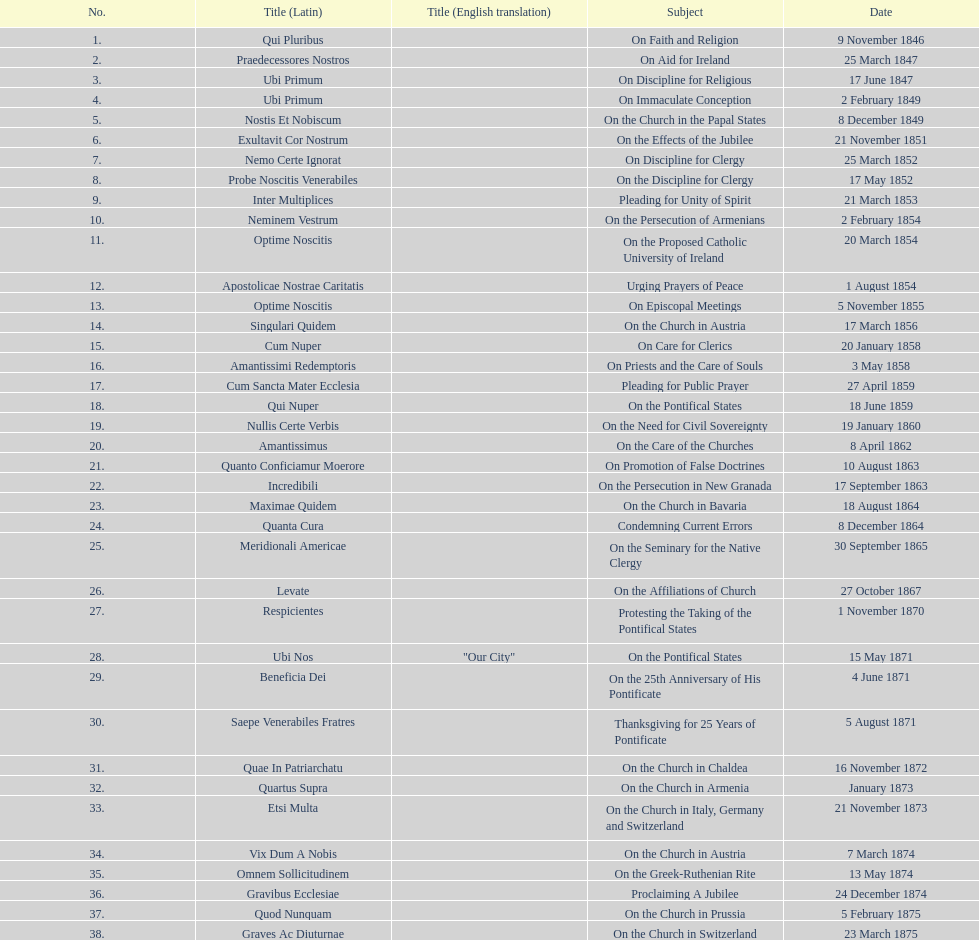How many subjects are there? 38. 